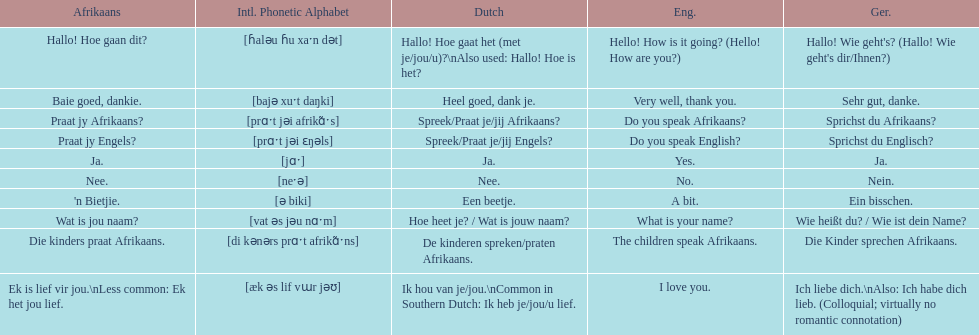How do you say 'do you speak afrikaans?' in afrikaans? Praat jy Afrikaans?. 